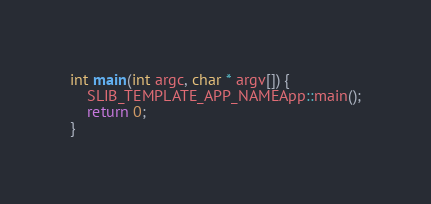<code> <loc_0><loc_0><loc_500><loc_500><_ObjectiveC_>
int main(int argc, char * argv[]) {
	SLIB_TEMPLATE_APP_NAMEApp::main();
	return 0;
}
</code> 